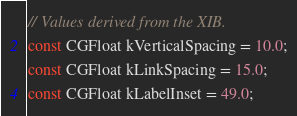Convert code to text. <code><loc_0><loc_0><loc_500><loc_500><_ObjectiveC_>// Values derived from the XIB.
const CGFloat kVerticalSpacing = 10.0;
const CGFloat kLinkSpacing = 15.0;
const CGFloat kLabelInset = 49.0;
</code> 